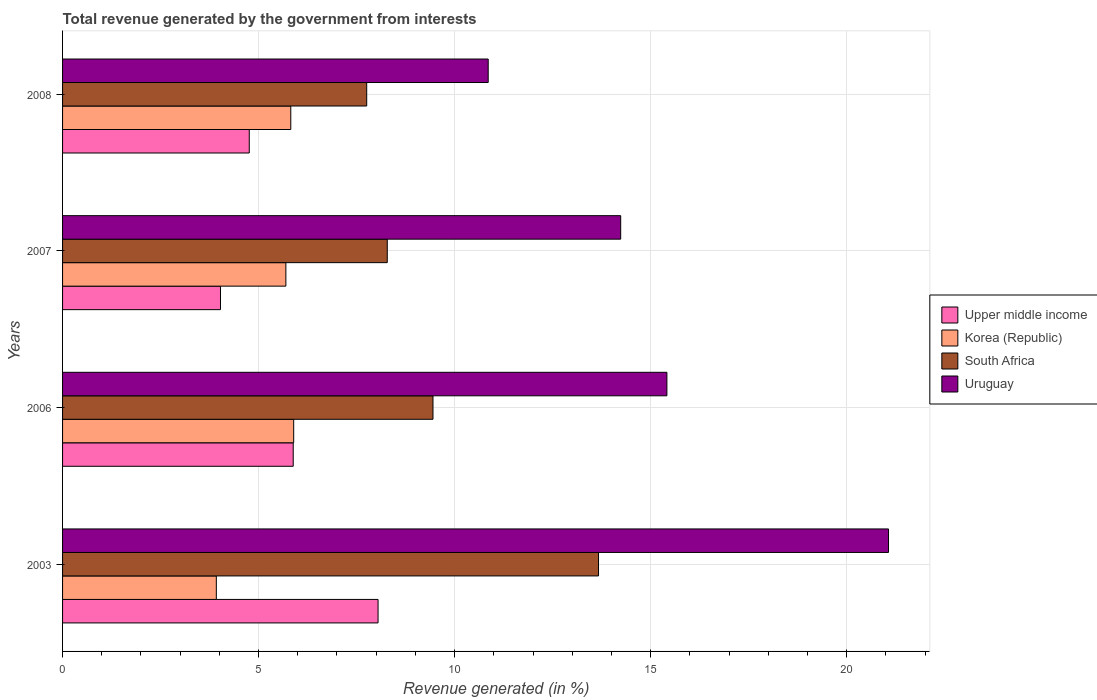Are the number of bars per tick equal to the number of legend labels?
Keep it short and to the point. Yes. How many bars are there on the 3rd tick from the bottom?
Offer a very short reply. 4. What is the label of the 3rd group of bars from the top?
Make the answer very short. 2006. In how many cases, is the number of bars for a given year not equal to the number of legend labels?
Ensure brevity in your answer.  0. What is the total revenue generated in Upper middle income in 2003?
Your response must be concise. 8.05. Across all years, what is the maximum total revenue generated in Upper middle income?
Your answer should be compact. 8.05. Across all years, what is the minimum total revenue generated in South Africa?
Your answer should be compact. 7.76. In which year was the total revenue generated in Korea (Republic) maximum?
Your answer should be very brief. 2006. In which year was the total revenue generated in South Africa minimum?
Your answer should be compact. 2008. What is the total total revenue generated in Uruguay in the graph?
Ensure brevity in your answer.  61.58. What is the difference between the total revenue generated in Korea (Republic) in 2006 and that in 2007?
Provide a succinct answer. 0.2. What is the difference between the total revenue generated in Korea (Republic) in 2006 and the total revenue generated in Uruguay in 2003?
Offer a terse response. -15.17. What is the average total revenue generated in Upper middle income per year?
Make the answer very short. 5.68. In the year 2008, what is the difference between the total revenue generated in Uruguay and total revenue generated in Upper middle income?
Your answer should be compact. 6.1. In how many years, is the total revenue generated in Korea (Republic) greater than 1 %?
Give a very brief answer. 4. What is the ratio of the total revenue generated in Korea (Republic) in 2003 to that in 2007?
Your answer should be compact. 0.69. Is the difference between the total revenue generated in Uruguay in 2006 and 2008 greater than the difference between the total revenue generated in Upper middle income in 2006 and 2008?
Offer a terse response. Yes. What is the difference between the highest and the second highest total revenue generated in Korea (Republic)?
Your answer should be compact. 0.07. What is the difference between the highest and the lowest total revenue generated in Korea (Republic)?
Your answer should be very brief. 1.97. Is the sum of the total revenue generated in Upper middle income in 2003 and 2007 greater than the maximum total revenue generated in Uruguay across all years?
Your response must be concise. No. Is it the case that in every year, the sum of the total revenue generated in South Africa and total revenue generated in Uruguay is greater than the sum of total revenue generated in Upper middle income and total revenue generated in Korea (Republic)?
Make the answer very short. Yes. What does the 4th bar from the top in 2003 represents?
Provide a short and direct response. Upper middle income. What does the 3rd bar from the bottom in 2008 represents?
Give a very brief answer. South Africa. Are all the bars in the graph horizontal?
Your response must be concise. Yes. How many years are there in the graph?
Keep it short and to the point. 4. Does the graph contain any zero values?
Provide a succinct answer. No. Does the graph contain grids?
Your response must be concise. Yes. How are the legend labels stacked?
Provide a short and direct response. Vertical. What is the title of the graph?
Offer a very short reply. Total revenue generated by the government from interests. Does "Iraq" appear as one of the legend labels in the graph?
Your response must be concise. No. What is the label or title of the X-axis?
Make the answer very short. Revenue generated (in %). What is the label or title of the Y-axis?
Provide a succinct answer. Years. What is the Revenue generated (in %) in Upper middle income in 2003?
Make the answer very short. 8.05. What is the Revenue generated (in %) of Korea (Republic) in 2003?
Provide a succinct answer. 3.92. What is the Revenue generated (in %) of South Africa in 2003?
Give a very brief answer. 13.67. What is the Revenue generated (in %) in Uruguay in 2003?
Ensure brevity in your answer.  21.07. What is the Revenue generated (in %) of Upper middle income in 2006?
Ensure brevity in your answer.  5.88. What is the Revenue generated (in %) in Korea (Republic) in 2006?
Your response must be concise. 5.9. What is the Revenue generated (in %) of South Africa in 2006?
Your answer should be very brief. 9.45. What is the Revenue generated (in %) of Uruguay in 2006?
Ensure brevity in your answer.  15.42. What is the Revenue generated (in %) in Upper middle income in 2007?
Your response must be concise. 4.03. What is the Revenue generated (in %) in Korea (Republic) in 2007?
Make the answer very short. 5.7. What is the Revenue generated (in %) in South Africa in 2007?
Your answer should be compact. 8.28. What is the Revenue generated (in %) of Uruguay in 2007?
Your response must be concise. 14.24. What is the Revenue generated (in %) of Upper middle income in 2008?
Offer a terse response. 4.76. What is the Revenue generated (in %) of Korea (Republic) in 2008?
Your response must be concise. 5.82. What is the Revenue generated (in %) of South Africa in 2008?
Provide a succinct answer. 7.76. What is the Revenue generated (in %) of Uruguay in 2008?
Make the answer very short. 10.86. Across all years, what is the maximum Revenue generated (in %) in Upper middle income?
Offer a terse response. 8.05. Across all years, what is the maximum Revenue generated (in %) of Korea (Republic)?
Give a very brief answer. 5.9. Across all years, what is the maximum Revenue generated (in %) of South Africa?
Your response must be concise. 13.67. Across all years, what is the maximum Revenue generated (in %) of Uruguay?
Ensure brevity in your answer.  21.07. Across all years, what is the minimum Revenue generated (in %) of Upper middle income?
Provide a short and direct response. 4.03. Across all years, what is the minimum Revenue generated (in %) of Korea (Republic)?
Give a very brief answer. 3.92. Across all years, what is the minimum Revenue generated (in %) of South Africa?
Provide a succinct answer. 7.76. Across all years, what is the minimum Revenue generated (in %) of Uruguay?
Give a very brief answer. 10.86. What is the total Revenue generated (in %) in Upper middle income in the graph?
Ensure brevity in your answer.  22.72. What is the total Revenue generated (in %) in Korea (Republic) in the graph?
Offer a terse response. 21.34. What is the total Revenue generated (in %) in South Africa in the graph?
Make the answer very short. 39.16. What is the total Revenue generated (in %) of Uruguay in the graph?
Provide a succinct answer. 61.58. What is the difference between the Revenue generated (in %) in Upper middle income in 2003 and that in 2006?
Provide a short and direct response. 2.16. What is the difference between the Revenue generated (in %) of Korea (Republic) in 2003 and that in 2006?
Give a very brief answer. -1.97. What is the difference between the Revenue generated (in %) of South Africa in 2003 and that in 2006?
Ensure brevity in your answer.  4.22. What is the difference between the Revenue generated (in %) of Uruguay in 2003 and that in 2006?
Offer a terse response. 5.65. What is the difference between the Revenue generated (in %) in Upper middle income in 2003 and that in 2007?
Give a very brief answer. 4.02. What is the difference between the Revenue generated (in %) of Korea (Republic) in 2003 and that in 2007?
Offer a very short reply. -1.77. What is the difference between the Revenue generated (in %) of South Africa in 2003 and that in 2007?
Make the answer very short. 5.39. What is the difference between the Revenue generated (in %) in Uruguay in 2003 and that in 2007?
Offer a terse response. 6.83. What is the difference between the Revenue generated (in %) in Upper middle income in 2003 and that in 2008?
Ensure brevity in your answer.  3.29. What is the difference between the Revenue generated (in %) in Korea (Republic) in 2003 and that in 2008?
Provide a succinct answer. -1.9. What is the difference between the Revenue generated (in %) in South Africa in 2003 and that in 2008?
Offer a terse response. 5.91. What is the difference between the Revenue generated (in %) in Uruguay in 2003 and that in 2008?
Offer a terse response. 10.21. What is the difference between the Revenue generated (in %) of Upper middle income in 2006 and that in 2007?
Your answer should be compact. 1.86. What is the difference between the Revenue generated (in %) of Korea (Republic) in 2006 and that in 2007?
Give a very brief answer. 0.2. What is the difference between the Revenue generated (in %) in South Africa in 2006 and that in 2007?
Offer a terse response. 1.17. What is the difference between the Revenue generated (in %) in Uruguay in 2006 and that in 2007?
Keep it short and to the point. 1.18. What is the difference between the Revenue generated (in %) of Upper middle income in 2006 and that in 2008?
Offer a very short reply. 1.12. What is the difference between the Revenue generated (in %) of Korea (Republic) in 2006 and that in 2008?
Offer a terse response. 0.07. What is the difference between the Revenue generated (in %) of South Africa in 2006 and that in 2008?
Provide a short and direct response. 1.69. What is the difference between the Revenue generated (in %) of Uruguay in 2006 and that in 2008?
Keep it short and to the point. 4.56. What is the difference between the Revenue generated (in %) of Upper middle income in 2007 and that in 2008?
Make the answer very short. -0.73. What is the difference between the Revenue generated (in %) of Korea (Republic) in 2007 and that in 2008?
Your answer should be compact. -0.12. What is the difference between the Revenue generated (in %) in South Africa in 2007 and that in 2008?
Your answer should be very brief. 0.52. What is the difference between the Revenue generated (in %) of Uruguay in 2007 and that in 2008?
Offer a terse response. 3.38. What is the difference between the Revenue generated (in %) of Upper middle income in 2003 and the Revenue generated (in %) of Korea (Republic) in 2006?
Provide a succinct answer. 2.15. What is the difference between the Revenue generated (in %) in Upper middle income in 2003 and the Revenue generated (in %) in South Africa in 2006?
Offer a very short reply. -1.4. What is the difference between the Revenue generated (in %) in Upper middle income in 2003 and the Revenue generated (in %) in Uruguay in 2006?
Make the answer very short. -7.37. What is the difference between the Revenue generated (in %) in Korea (Republic) in 2003 and the Revenue generated (in %) in South Africa in 2006?
Provide a short and direct response. -5.53. What is the difference between the Revenue generated (in %) of Korea (Republic) in 2003 and the Revenue generated (in %) of Uruguay in 2006?
Your answer should be compact. -11.49. What is the difference between the Revenue generated (in %) of South Africa in 2003 and the Revenue generated (in %) of Uruguay in 2006?
Provide a succinct answer. -1.74. What is the difference between the Revenue generated (in %) of Upper middle income in 2003 and the Revenue generated (in %) of Korea (Republic) in 2007?
Ensure brevity in your answer.  2.35. What is the difference between the Revenue generated (in %) of Upper middle income in 2003 and the Revenue generated (in %) of South Africa in 2007?
Your response must be concise. -0.23. What is the difference between the Revenue generated (in %) in Upper middle income in 2003 and the Revenue generated (in %) in Uruguay in 2007?
Offer a very short reply. -6.19. What is the difference between the Revenue generated (in %) of Korea (Republic) in 2003 and the Revenue generated (in %) of South Africa in 2007?
Make the answer very short. -4.36. What is the difference between the Revenue generated (in %) of Korea (Republic) in 2003 and the Revenue generated (in %) of Uruguay in 2007?
Provide a short and direct response. -10.31. What is the difference between the Revenue generated (in %) of South Africa in 2003 and the Revenue generated (in %) of Uruguay in 2007?
Offer a terse response. -0.57. What is the difference between the Revenue generated (in %) of Upper middle income in 2003 and the Revenue generated (in %) of Korea (Republic) in 2008?
Offer a terse response. 2.23. What is the difference between the Revenue generated (in %) of Upper middle income in 2003 and the Revenue generated (in %) of South Africa in 2008?
Give a very brief answer. 0.29. What is the difference between the Revenue generated (in %) of Upper middle income in 2003 and the Revenue generated (in %) of Uruguay in 2008?
Your answer should be very brief. -2.81. What is the difference between the Revenue generated (in %) of Korea (Republic) in 2003 and the Revenue generated (in %) of South Africa in 2008?
Offer a terse response. -3.84. What is the difference between the Revenue generated (in %) in Korea (Republic) in 2003 and the Revenue generated (in %) in Uruguay in 2008?
Your answer should be compact. -6.94. What is the difference between the Revenue generated (in %) of South Africa in 2003 and the Revenue generated (in %) of Uruguay in 2008?
Make the answer very short. 2.81. What is the difference between the Revenue generated (in %) of Upper middle income in 2006 and the Revenue generated (in %) of Korea (Republic) in 2007?
Provide a short and direct response. 0.19. What is the difference between the Revenue generated (in %) in Upper middle income in 2006 and the Revenue generated (in %) in South Africa in 2007?
Your answer should be compact. -2.4. What is the difference between the Revenue generated (in %) of Upper middle income in 2006 and the Revenue generated (in %) of Uruguay in 2007?
Offer a very short reply. -8.35. What is the difference between the Revenue generated (in %) of Korea (Republic) in 2006 and the Revenue generated (in %) of South Africa in 2007?
Offer a terse response. -2.39. What is the difference between the Revenue generated (in %) in Korea (Republic) in 2006 and the Revenue generated (in %) in Uruguay in 2007?
Your answer should be very brief. -8.34. What is the difference between the Revenue generated (in %) of South Africa in 2006 and the Revenue generated (in %) of Uruguay in 2007?
Your response must be concise. -4.79. What is the difference between the Revenue generated (in %) in Upper middle income in 2006 and the Revenue generated (in %) in Korea (Republic) in 2008?
Your answer should be very brief. 0.06. What is the difference between the Revenue generated (in %) of Upper middle income in 2006 and the Revenue generated (in %) of South Africa in 2008?
Provide a succinct answer. -1.87. What is the difference between the Revenue generated (in %) in Upper middle income in 2006 and the Revenue generated (in %) in Uruguay in 2008?
Offer a terse response. -4.97. What is the difference between the Revenue generated (in %) in Korea (Republic) in 2006 and the Revenue generated (in %) in South Africa in 2008?
Offer a terse response. -1.86. What is the difference between the Revenue generated (in %) of Korea (Republic) in 2006 and the Revenue generated (in %) of Uruguay in 2008?
Offer a very short reply. -4.96. What is the difference between the Revenue generated (in %) in South Africa in 2006 and the Revenue generated (in %) in Uruguay in 2008?
Offer a terse response. -1.41. What is the difference between the Revenue generated (in %) of Upper middle income in 2007 and the Revenue generated (in %) of Korea (Republic) in 2008?
Keep it short and to the point. -1.79. What is the difference between the Revenue generated (in %) of Upper middle income in 2007 and the Revenue generated (in %) of South Africa in 2008?
Offer a terse response. -3.73. What is the difference between the Revenue generated (in %) in Upper middle income in 2007 and the Revenue generated (in %) in Uruguay in 2008?
Offer a terse response. -6.83. What is the difference between the Revenue generated (in %) of Korea (Republic) in 2007 and the Revenue generated (in %) of South Africa in 2008?
Offer a very short reply. -2.06. What is the difference between the Revenue generated (in %) in Korea (Republic) in 2007 and the Revenue generated (in %) in Uruguay in 2008?
Your answer should be compact. -5.16. What is the difference between the Revenue generated (in %) of South Africa in 2007 and the Revenue generated (in %) of Uruguay in 2008?
Offer a very short reply. -2.57. What is the average Revenue generated (in %) in Upper middle income per year?
Ensure brevity in your answer.  5.68. What is the average Revenue generated (in %) of Korea (Republic) per year?
Provide a short and direct response. 5.33. What is the average Revenue generated (in %) in South Africa per year?
Offer a terse response. 9.79. What is the average Revenue generated (in %) of Uruguay per year?
Offer a very short reply. 15.39. In the year 2003, what is the difference between the Revenue generated (in %) in Upper middle income and Revenue generated (in %) in Korea (Republic)?
Keep it short and to the point. 4.13. In the year 2003, what is the difference between the Revenue generated (in %) of Upper middle income and Revenue generated (in %) of South Africa?
Give a very brief answer. -5.62. In the year 2003, what is the difference between the Revenue generated (in %) of Upper middle income and Revenue generated (in %) of Uruguay?
Keep it short and to the point. -13.02. In the year 2003, what is the difference between the Revenue generated (in %) in Korea (Republic) and Revenue generated (in %) in South Africa?
Offer a terse response. -9.75. In the year 2003, what is the difference between the Revenue generated (in %) of Korea (Republic) and Revenue generated (in %) of Uruguay?
Make the answer very short. -17.15. In the year 2003, what is the difference between the Revenue generated (in %) of South Africa and Revenue generated (in %) of Uruguay?
Your answer should be compact. -7.4. In the year 2006, what is the difference between the Revenue generated (in %) in Upper middle income and Revenue generated (in %) in Korea (Republic)?
Give a very brief answer. -0.01. In the year 2006, what is the difference between the Revenue generated (in %) in Upper middle income and Revenue generated (in %) in South Africa?
Your response must be concise. -3.57. In the year 2006, what is the difference between the Revenue generated (in %) in Upper middle income and Revenue generated (in %) in Uruguay?
Provide a succinct answer. -9.53. In the year 2006, what is the difference between the Revenue generated (in %) in Korea (Republic) and Revenue generated (in %) in South Africa?
Offer a terse response. -3.55. In the year 2006, what is the difference between the Revenue generated (in %) of Korea (Republic) and Revenue generated (in %) of Uruguay?
Ensure brevity in your answer.  -9.52. In the year 2006, what is the difference between the Revenue generated (in %) in South Africa and Revenue generated (in %) in Uruguay?
Provide a short and direct response. -5.97. In the year 2007, what is the difference between the Revenue generated (in %) in Upper middle income and Revenue generated (in %) in Korea (Republic)?
Provide a short and direct response. -1.67. In the year 2007, what is the difference between the Revenue generated (in %) of Upper middle income and Revenue generated (in %) of South Africa?
Make the answer very short. -4.25. In the year 2007, what is the difference between the Revenue generated (in %) in Upper middle income and Revenue generated (in %) in Uruguay?
Offer a terse response. -10.21. In the year 2007, what is the difference between the Revenue generated (in %) in Korea (Republic) and Revenue generated (in %) in South Africa?
Your answer should be very brief. -2.59. In the year 2007, what is the difference between the Revenue generated (in %) in Korea (Republic) and Revenue generated (in %) in Uruguay?
Provide a short and direct response. -8.54. In the year 2007, what is the difference between the Revenue generated (in %) of South Africa and Revenue generated (in %) of Uruguay?
Offer a very short reply. -5.95. In the year 2008, what is the difference between the Revenue generated (in %) of Upper middle income and Revenue generated (in %) of Korea (Republic)?
Your answer should be compact. -1.06. In the year 2008, what is the difference between the Revenue generated (in %) in Upper middle income and Revenue generated (in %) in South Africa?
Your answer should be compact. -3. In the year 2008, what is the difference between the Revenue generated (in %) of Upper middle income and Revenue generated (in %) of Uruguay?
Keep it short and to the point. -6.09. In the year 2008, what is the difference between the Revenue generated (in %) of Korea (Republic) and Revenue generated (in %) of South Africa?
Your answer should be very brief. -1.94. In the year 2008, what is the difference between the Revenue generated (in %) in Korea (Republic) and Revenue generated (in %) in Uruguay?
Ensure brevity in your answer.  -5.04. In the year 2008, what is the difference between the Revenue generated (in %) of South Africa and Revenue generated (in %) of Uruguay?
Your response must be concise. -3.1. What is the ratio of the Revenue generated (in %) of Upper middle income in 2003 to that in 2006?
Keep it short and to the point. 1.37. What is the ratio of the Revenue generated (in %) of Korea (Republic) in 2003 to that in 2006?
Keep it short and to the point. 0.67. What is the ratio of the Revenue generated (in %) of South Africa in 2003 to that in 2006?
Make the answer very short. 1.45. What is the ratio of the Revenue generated (in %) of Uruguay in 2003 to that in 2006?
Offer a very short reply. 1.37. What is the ratio of the Revenue generated (in %) of Upper middle income in 2003 to that in 2007?
Provide a short and direct response. 2. What is the ratio of the Revenue generated (in %) in Korea (Republic) in 2003 to that in 2007?
Make the answer very short. 0.69. What is the ratio of the Revenue generated (in %) in South Africa in 2003 to that in 2007?
Offer a very short reply. 1.65. What is the ratio of the Revenue generated (in %) of Uruguay in 2003 to that in 2007?
Provide a short and direct response. 1.48. What is the ratio of the Revenue generated (in %) in Upper middle income in 2003 to that in 2008?
Make the answer very short. 1.69. What is the ratio of the Revenue generated (in %) of Korea (Republic) in 2003 to that in 2008?
Provide a short and direct response. 0.67. What is the ratio of the Revenue generated (in %) in South Africa in 2003 to that in 2008?
Offer a very short reply. 1.76. What is the ratio of the Revenue generated (in %) in Uruguay in 2003 to that in 2008?
Give a very brief answer. 1.94. What is the ratio of the Revenue generated (in %) in Upper middle income in 2006 to that in 2007?
Your answer should be very brief. 1.46. What is the ratio of the Revenue generated (in %) of Korea (Republic) in 2006 to that in 2007?
Offer a terse response. 1.03. What is the ratio of the Revenue generated (in %) of South Africa in 2006 to that in 2007?
Give a very brief answer. 1.14. What is the ratio of the Revenue generated (in %) of Uruguay in 2006 to that in 2007?
Offer a very short reply. 1.08. What is the ratio of the Revenue generated (in %) of Upper middle income in 2006 to that in 2008?
Offer a very short reply. 1.24. What is the ratio of the Revenue generated (in %) of Korea (Republic) in 2006 to that in 2008?
Your response must be concise. 1.01. What is the ratio of the Revenue generated (in %) in South Africa in 2006 to that in 2008?
Ensure brevity in your answer.  1.22. What is the ratio of the Revenue generated (in %) of Uruguay in 2006 to that in 2008?
Your response must be concise. 1.42. What is the ratio of the Revenue generated (in %) of Upper middle income in 2007 to that in 2008?
Keep it short and to the point. 0.85. What is the ratio of the Revenue generated (in %) of Korea (Republic) in 2007 to that in 2008?
Give a very brief answer. 0.98. What is the ratio of the Revenue generated (in %) of South Africa in 2007 to that in 2008?
Offer a very short reply. 1.07. What is the ratio of the Revenue generated (in %) of Uruguay in 2007 to that in 2008?
Make the answer very short. 1.31. What is the difference between the highest and the second highest Revenue generated (in %) of Upper middle income?
Keep it short and to the point. 2.16. What is the difference between the highest and the second highest Revenue generated (in %) in Korea (Republic)?
Make the answer very short. 0.07. What is the difference between the highest and the second highest Revenue generated (in %) in South Africa?
Your answer should be compact. 4.22. What is the difference between the highest and the second highest Revenue generated (in %) in Uruguay?
Offer a terse response. 5.65. What is the difference between the highest and the lowest Revenue generated (in %) in Upper middle income?
Ensure brevity in your answer.  4.02. What is the difference between the highest and the lowest Revenue generated (in %) of Korea (Republic)?
Give a very brief answer. 1.97. What is the difference between the highest and the lowest Revenue generated (in %) in South Africa?
Your answer should be very brief. 5.91. What is the difference between the highest and the lowest Revenue generated (in %) in Uruguay?
Your answer should be compact. 10.21. 